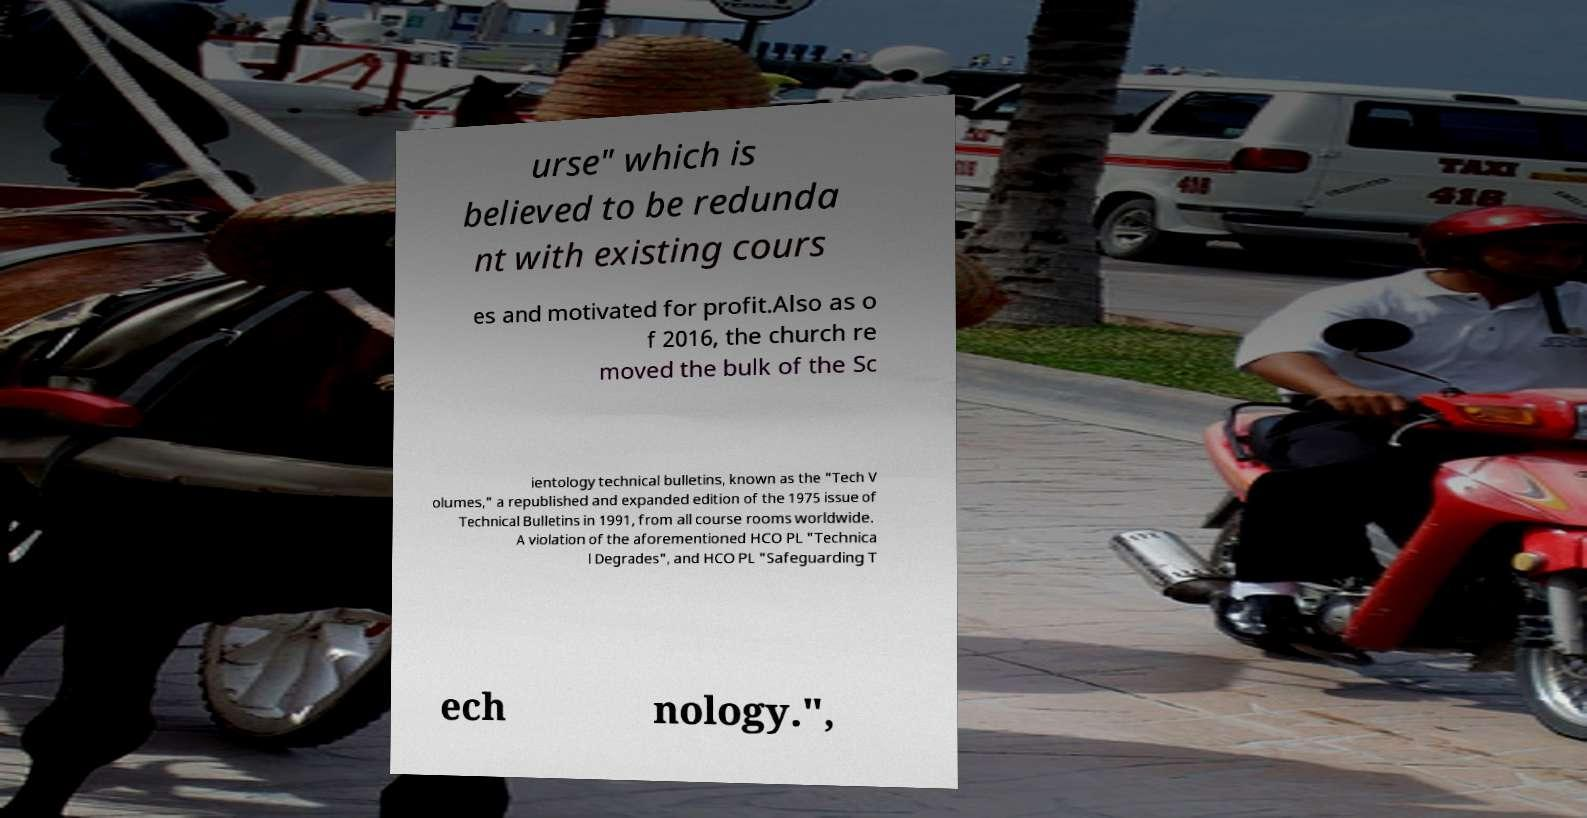What messages or text are displayed in this image? I need them in a readable, typed format. urse" which is believed to be redunda nt with existing cours es and motivated for profit.Also as o f 2016, the church re moved the bulk of the Sc ientology technical bulletins, known as the "Tech V olumes," a republished and expanded edition of the 1975 issue of Technical Bulletins in 1991, from all course rooms worldwide. A violation of the aforementioned HCO PL "Technica l Degrades", and HCO PL "Safeguarding T ech nology.", 